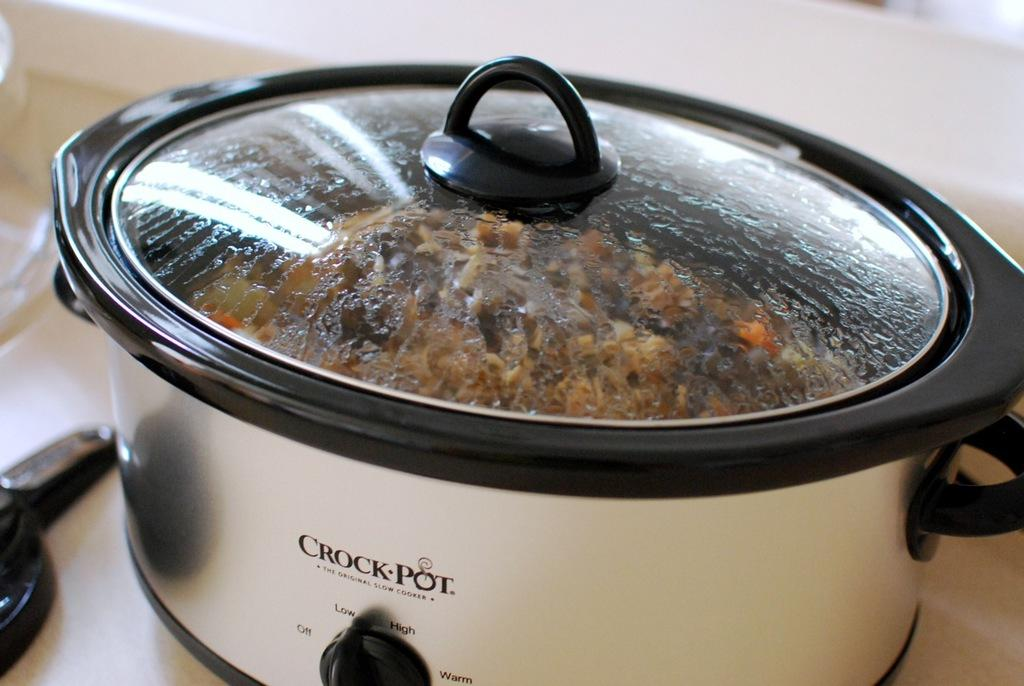<image>
Summarize the visual content of the image. A crock pot with food in it and a lid on it. 